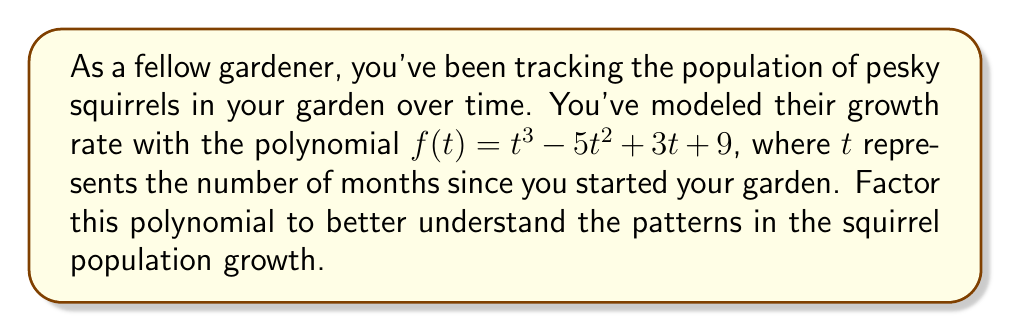Can you answer this question? Let's approach this step-by-step:

1) First, we should check if there are any rational roots using the rational root theorem. The possible rational roots are the factors of the constant term: $\pm 1, \pm 3, \pm 9$.

2) Testing these values, we find that $f(3) = 0$. So $(t-3)$ is a factor.

3) We can use polynomial long division to divide $f(t)$ by $(t-3)$:

   $$\frac{t^3 - 5t^2 + 3t + 9}{t - 3} = t^2 - 2t - 3$$

4) So now we have: $f(t) = (t-3)(t^2 - 2t - 3)$

5) We need to factor the quadratic term $t^2 - 2t - 3$. We can do this by finding two numbers that multiply to give $-3$ and add to give $-2$. These numbers are $-3$ and $1$.

6) Therefore, $t^2 - 2t - 3 = (t-3)(t+1)$

7) Combining all of this, we get the final factored form:

   $$f(t) = (t-3)(t-3)(t+1) = (t-3)^2(t+1)$$

This factored form tells us that the squirrel population growth rate will be zero when $t=3$ (with multiplicity 2) and when $t=-1$.
Answer: $f(t) = (t-3)^2(t+1)$ 